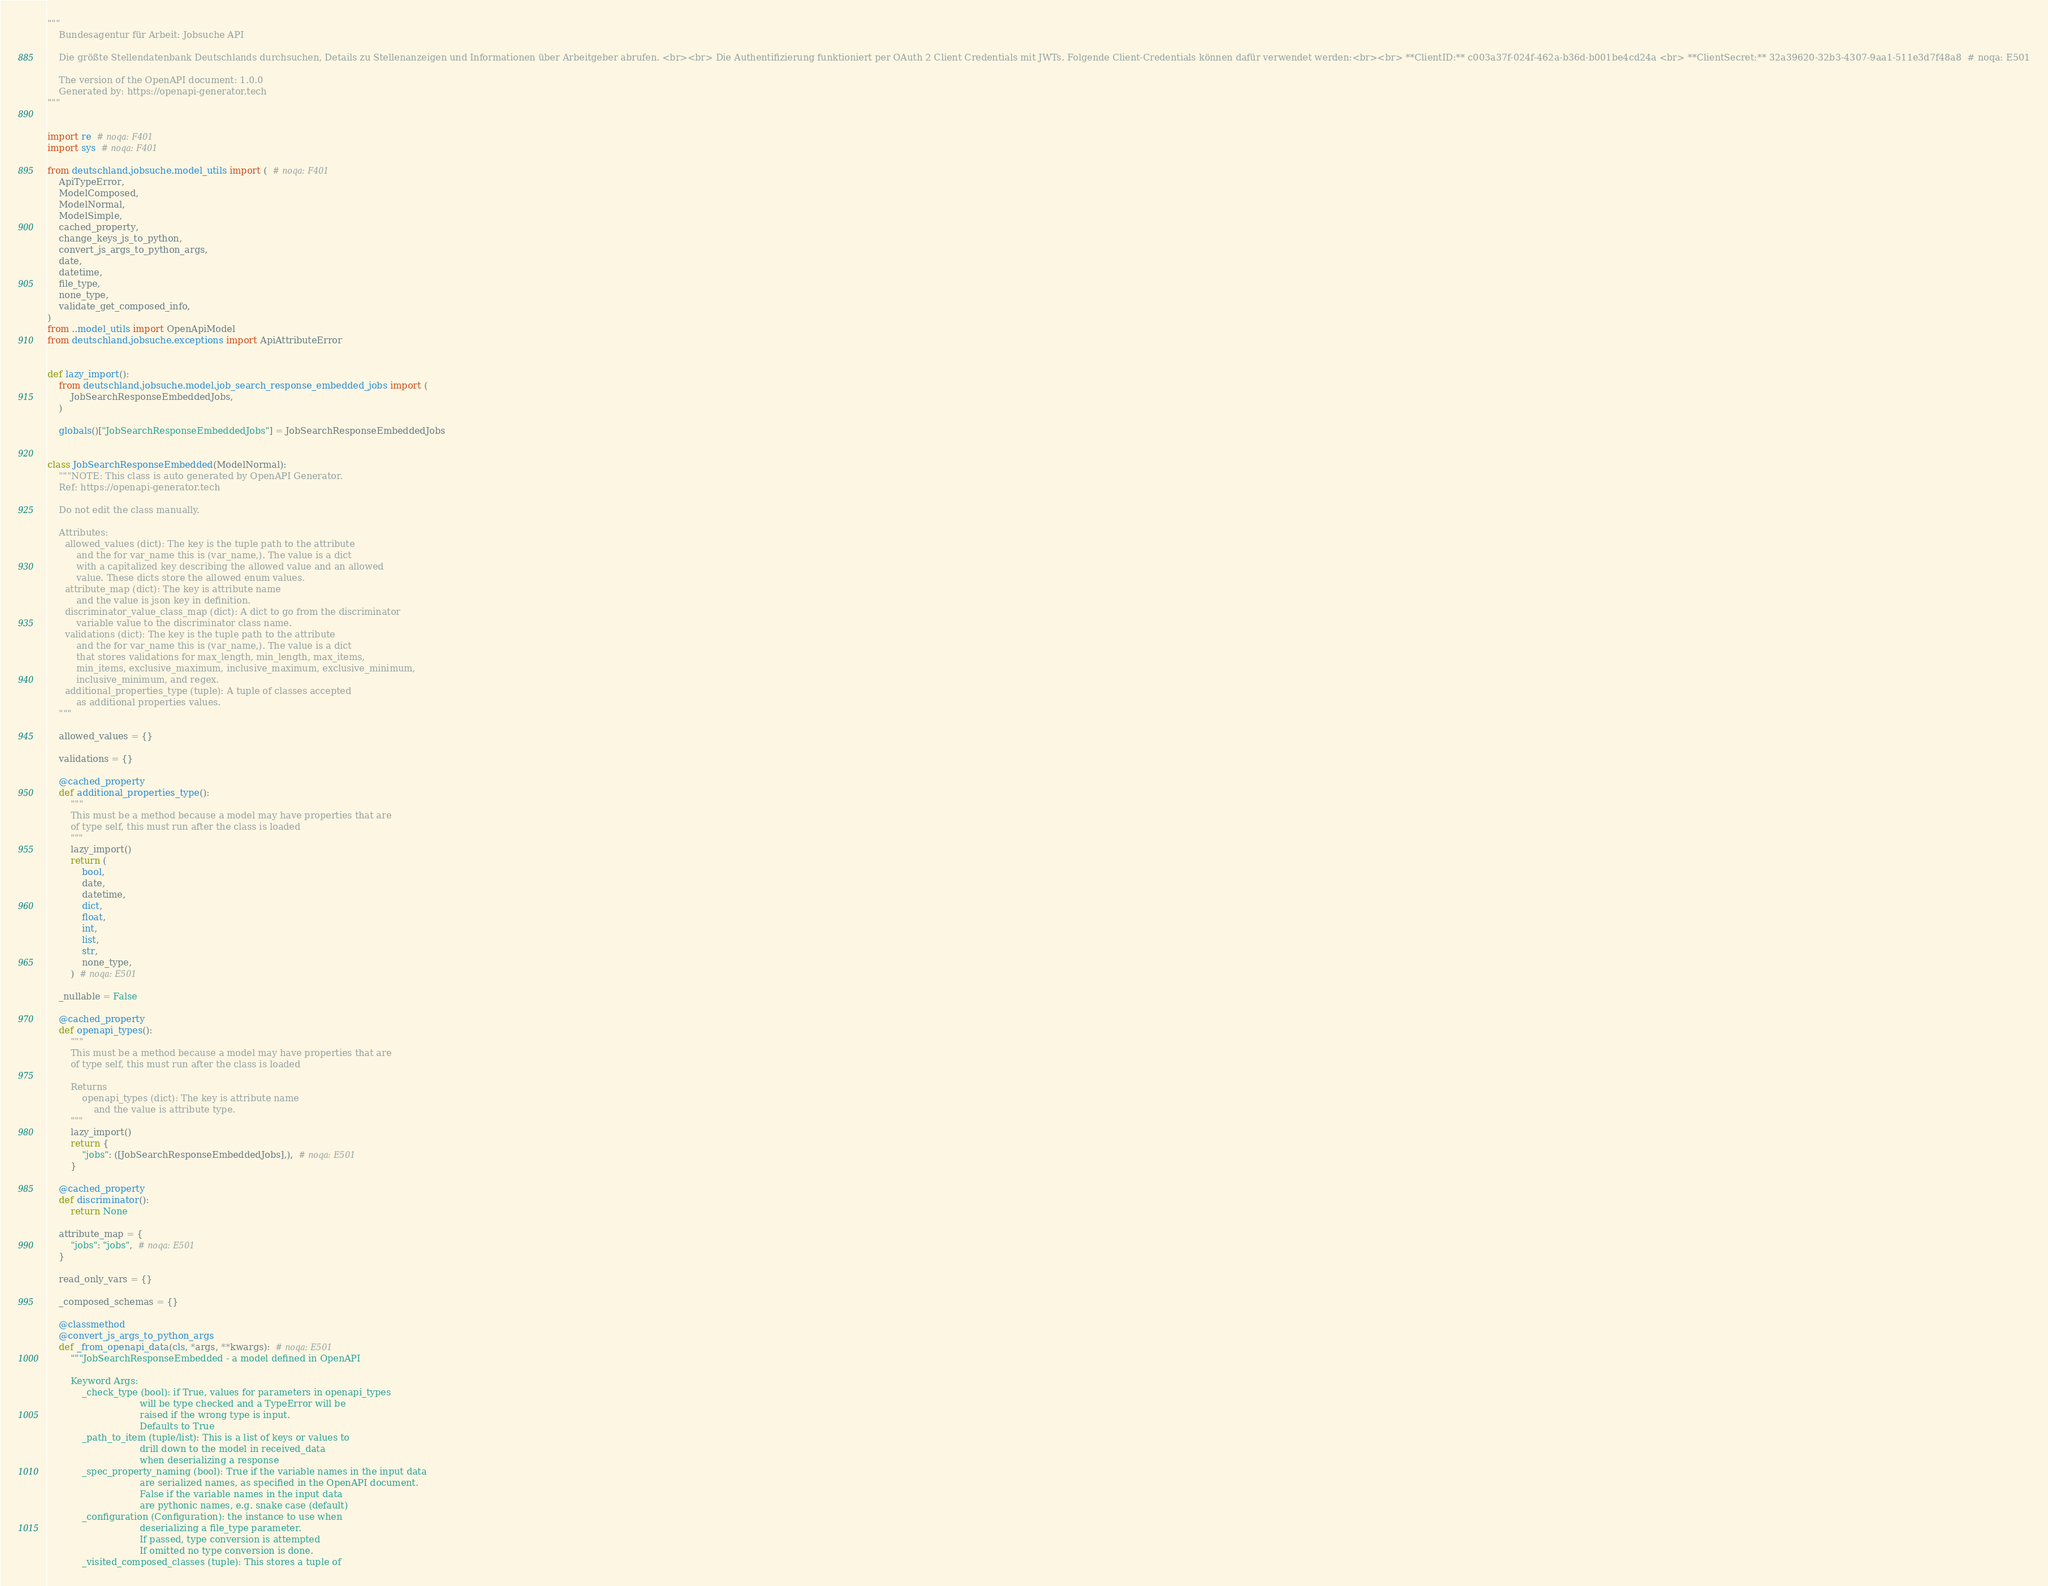<code> <loc_0><loc_0><loc_500><loc_500><_Python_>"""
    Bundesagentur für Arbeit: Jobsuche API

    Die größte Stellendatenbank Deutschlands durchsuchen, Details zu Stellenanzeigen und Informationen über Arbeitgeber abrufen. <br><br> Die Authentifizierung funktioniert per OAuth 2 Client Credentials mit JWTs. Folgende Client-Credentials können dafür verwendet werden:<br><br> **ClientID:** c003a37f-024f-462a-b36d-b001be4cd24a <br> **ClientSecret:** 32a39620-32b3-4307-9aa1-511e3d7f48a8  # noqa: E501

    The version of the OpenAPI document: 1.0.0
    Generated by: https://openapi-generator.tech
"""


import re  # noqa: F401
import sys  # noqa: F401

from deutschland.jobsuche.model_utils import (  # noqa: F401
    ApiTypeError,
    ModelComposed,
    ModelNormal,
    ModelSimple,
    cached_property,
    change_keys_js_to_python,
    convert_js_args_to_python_args,
    date,
    datetime,
    file_type,
    none_type,
    validate_get_composed_info,
)
from ..model_utils import OpenApiModel
from deutschland.jobsuche.exceptions import ApiAttributeError


def lazy_import():
    from deutschland.jobsuche.model.job_search_response_embedded_jobs import (
        JobSearchResponseEmbeddedJobs,
    )

    globals()["JobSearchResponseEmbeddedJobs"] = JobSearchResponseEmbeddedJobs


class JobSearchResponseEmbedded(ModelNormal):
    """NOTE: This class is auto generated by OpenAPI Generator.
    Ref: https://openapi-generator.tech

    Do not edit the class manually.

    Attributes:
      allowed_values (dict): The key is the tuple path to the attribute
          and the for var_name this is (var_name,). The value is a dict
          with a capitalized key describing the allowed value and an allowed
          value. These dicts store the allowed enum values.
      attribute_map (dict): The key is attribute name
          and the value is json key in definition.
      discriminator_value_class_map (dict): A dict to go from the discriminator
          variable value to the discriminator class name.
      validations (dict): The key is the tuple path to the attribute
          and the for var_name this is (var_name,). The value is a dict
          that stores validations for max_length, min_length, max_items,
          min_items, exclusive_maximum, inclusive_maximum, exclusive_minimum,
          inclusive_minimum, and regex.
      additional_properties_type (tuple): A tuple of classes accepted
          as additional properties values.
    """

    allowed_values = {}

    validations = {}

    @cached_property
    def additional_properties_type():
        """
        This must be a method because a model may have properties that are
        of type self, this must run after the class is loaded
        """
        lazy_import()
        return (
            bool,
            date,
            datetime,
            dict,
            float,
            int,
            list,
            str,
            none_type,
        )  # noqa: E501

    _nullable = False

    @cached_property
    def openapi_types():
        """
        This must be a method because a model may have properties that are
        of type self, this must run after the class is loaded

        Returns
            openapi_types (dict): The key is attribute name
                and the value is attribute type.
        """
        lazy_import()
        return {
            "jobs": ([JobSearchResponseEmbeddedJobs],),  # noqa: E501
        }

    @cached_property
    def discriminator():
        return None

    attribute_map = {
        "jobs": "jobs",  # noqa: E501
    }

    read_only_vars = {}

    _composed_schemas = {}

    @classmethod
    @convert_js_args_to_python_args
    def _from_openapi_data(cls, *args, **kwargs):  # noqa: E501
        """JobSearchResponseEmbedded - a model defined in OpenAPI

        Keyword Args:
            _check_type (bool): if True, values for parameters in openapi_types
                                will be type checked and a TypeError will be
                                raised if the wrong type is input.
                                Defaults to True
            _path_to_item (tuple/list): This is a list of keys or values to
                                drill down to the model in received_data
                                when deserializing a response
            _spec_property_naming (bool): True if the variable names in the input data
                                are serialized names, as specified in the OpenAPI document.
                                False if the variable names in the input data
                                are pythonic names, e.g. snake case (default)
            _configuration (Configuration): the instance to use when
                                deserializing a file_type parameter.
                                If passed, type conversion is attempted
                                If omitted no type conversion is done.
            _visited_composed_classes (tuple): This stores a tuple of</code> 